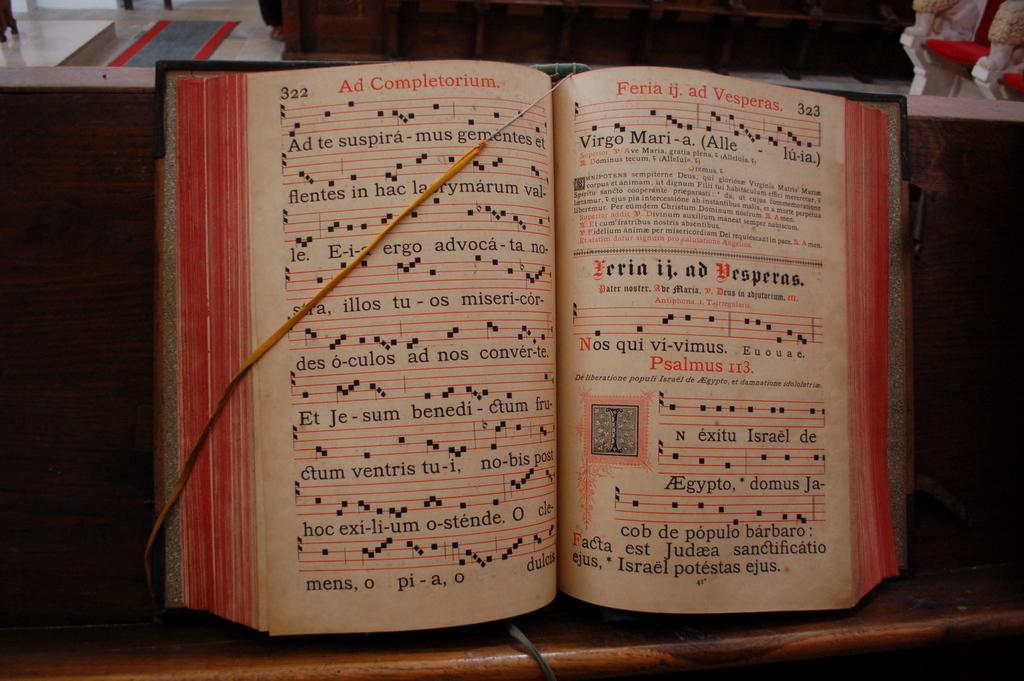Provide a one-sentence caption for the provided image. A book that is opened to pages titled Ad Complementorium and Feria ij. ad Vesperas. 